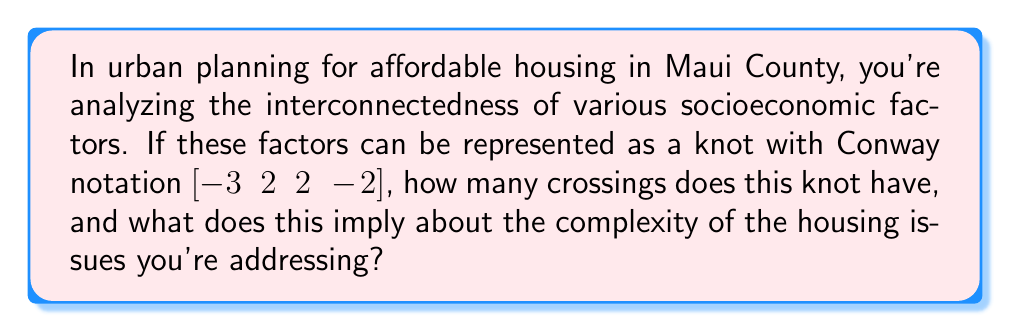What is the answer to this math problem? To solve this problem, we need to understand Conway notation and how it relates to knot crossings:

1) Conway notation represents a knot by describing how it alternates over and under itself.

2) Each number in the notation represents a crossing or a series of crossings:
   - Positive numbers indicate right-handed crossings
   - Negative numbers indicate left-handed crossings
   - The absolute value of each number represents the number of crossings in that section

3) For the given Conway notation [-3 2 2 -2]:
   $$|-3| + |2| + |2| + |-2| = 3 + 2 + 2 + 2 = 9$$

4) Therefore, this knot has 9 crossings.

5) In the context of urban planning and affordable housing:
   - Each crossing can represent an interconnected factor affecting housing
   - The number of crossings (9) suggests a high level of complexity in the housing issues
   - The mix of positive and negative numbers indicates that these factors have varied impacts and directions of influence

6) This complexity implies that addressing affordable housing in Maui County requires a multifaceted approach, considering at least 9 interconnected socioeconomic factors.
Answer: 9 crossings; high complexity in housing issues 